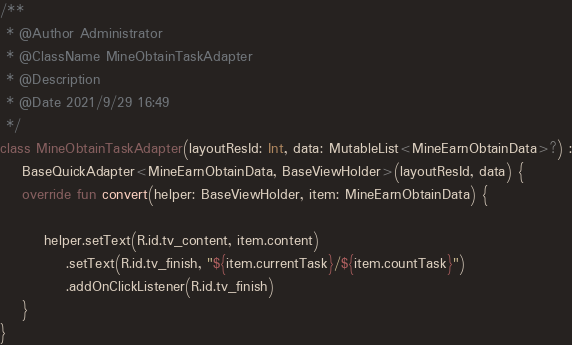<code> <loc_0><loc_0><loc_500><loc_500><_Kotlin_>
/**
 * @Author Administrator
 * @ClassName MineObtainTaskAdapter
 * @Description
 * @Date 2021/9/29 16:49
 */
class MineObtainTaskAdapter(layoutResId: Int, data: MutableList<MineEarnObtainData>?) :
    BaseQuickAdapter<MineEarnObtainData, BaseViewHolder>(layoutResId, data) {
    override fun convert(helper: BaseViewHolder, item: MineEarnObtainData) {

        helper.setText(R.id.tv_content, item.content)
            .setText(R.id.tv_finish, "${item.currentTask}/${item.countTask}")
            .addOnClickListener(R.id.tv_finish)
    }
}</code> 